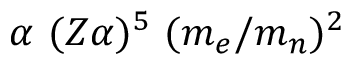<formula> <loc_0><loc_0><loc_500><loc_500>\alpha ( Z \alpha ) ^ { 5 } ( m _ { e } / m _ { n } ) ^ { 2 }</formula> 